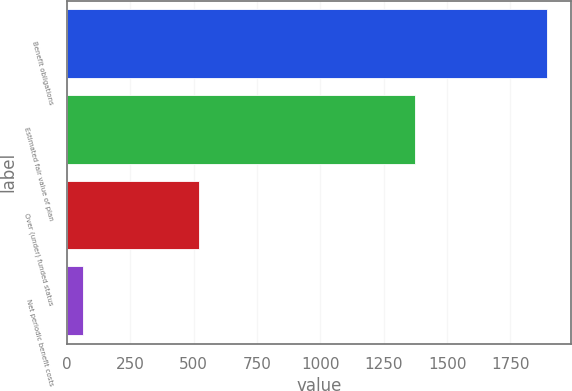<chart> <loc_0><loc_0><loc_500><loc_500><bar_chart><fcel>Benefit obligations<fcel>Estimated fair value of plan<fcel>Over (under) funded status<fcel>Net periodic benefit costs<nl><fcel>1895<fcel>1373<fcel>522<fcel>63<nl></chart> 